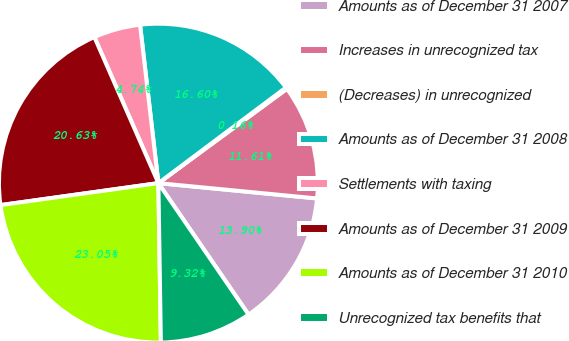<chart> <loc_0><loc_0><loc_500><loc_500><pie_chart><fcel>Amounts as of December 31 2007<fcel>Increases in unrecognized tax<fcel>(Decreases) in unrecognized<fcel>Amounts as of December 31 2008<fcel>Settlements with taxing<fcel>Amounts as of December 31 2009<fcel>Amounts as of December 31 2010<fcel>Unrecognized tax benefits that<nl><fcel>13.9%<fcel>11.61%<fcel>0.16%<fcel>16.6%<fcel>4.74%<fcel>20.63%<fcel>23.05%<fcel>9.32%<nl></chart> 